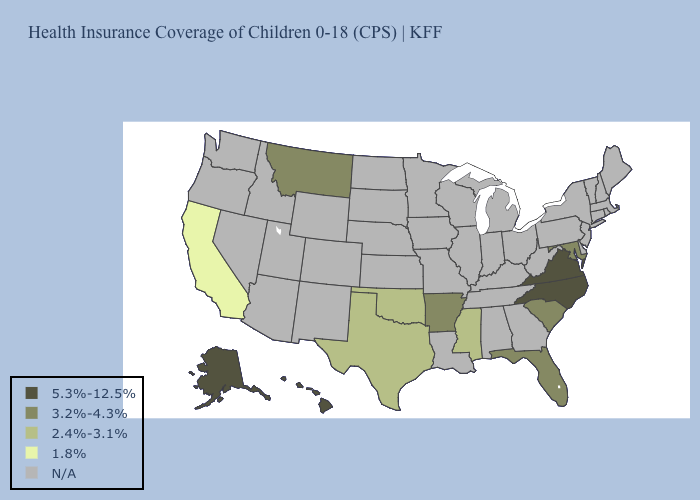What is the highest value in the USA?
Give a very brief answer. 5.3%-12.5%. What is the value of Iowa?
Keep it brief. N/A. Does North Carolina have the highest value in the USA?
Write a very short answer. Yes. What is the value of Iowa?
Short answer required. N/A. What is the highest value in the USA?
Short answer required. 5.3%-12.5%. What is the highest value in the USA?
Quick response, please. 5.3%-12.5%. Among the states that border Virginia , does Maryland have the highest value?
Give a very brief answer. No. What is the value of Montana?
Be succinct. 3.2%-4.3%. What is the value of Wisconsin?
Keep it brief. N/A. Name the states that have a value in the range 3.2%-4.3%?
Give a very brief answer. Arkansas, Florida, Maryland, Montana, South Carolina. Does the map have missing data?
Write a very short answer. Yes. Which states have the lowest value in the West?
Be succinct. California. 